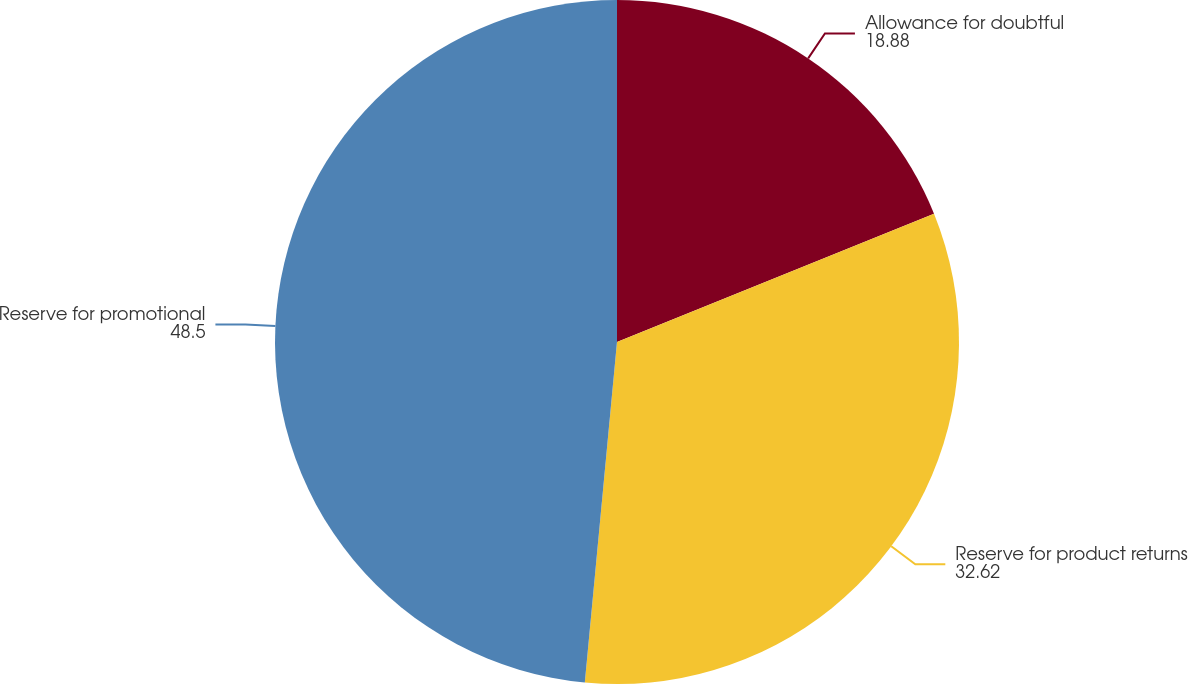Convert chart. <chart><loc_0><loc_0><loc_500><loc_500><pie_chart><fcel>Allowance for doubtful<fcel>Reserve for product returns<fcel>Reserve for promotional<nl><fcel>18.88%<fcel>32.62%<fcel>48.5%<nl></chart> 